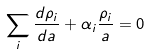Convert formula to latex. <formula><loc_0><loc_0><loc_500><loc_500>\sum _ { i } \frac { d \rho _ { i } } { d a } + \alpha _ { i } \frac { \rho _ { i } } { a } = 0</formula> 